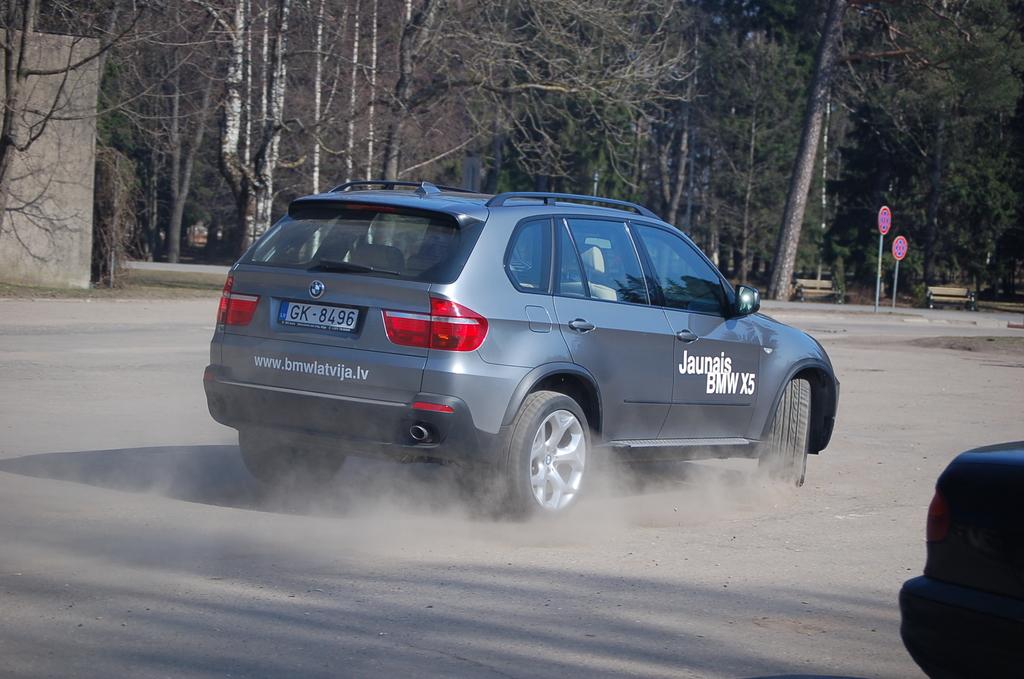What make and model is this car?
Provide a succinct answer. Bmw x5. 